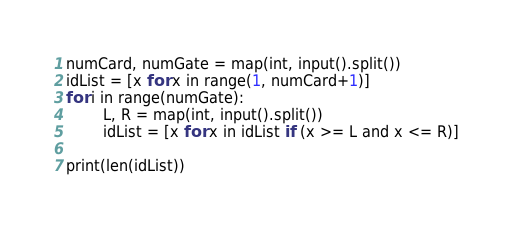<code> <loc_0><loc_0><loc_500><loc_500><_Python_>numCard, numGate = map(int, input().split())
idList = [x for x in range(1, numCard+1)]
for i in range(numGate):
        L, R = map(int, input().split())
        idList = [x for x in idList if (x >= L and x <= R)]

print(len(idList))</code> 